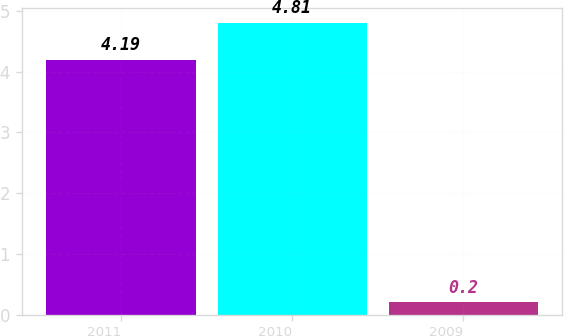Convert chart to OTSL. <chart><loc_0><loc_0><loc_500><loc_500><bar_chart><fcel>2011<fcel>2010<fcel>2009<nl><fcel>4.19<fcel>4.81<fcel>0.2<nl></chart> 